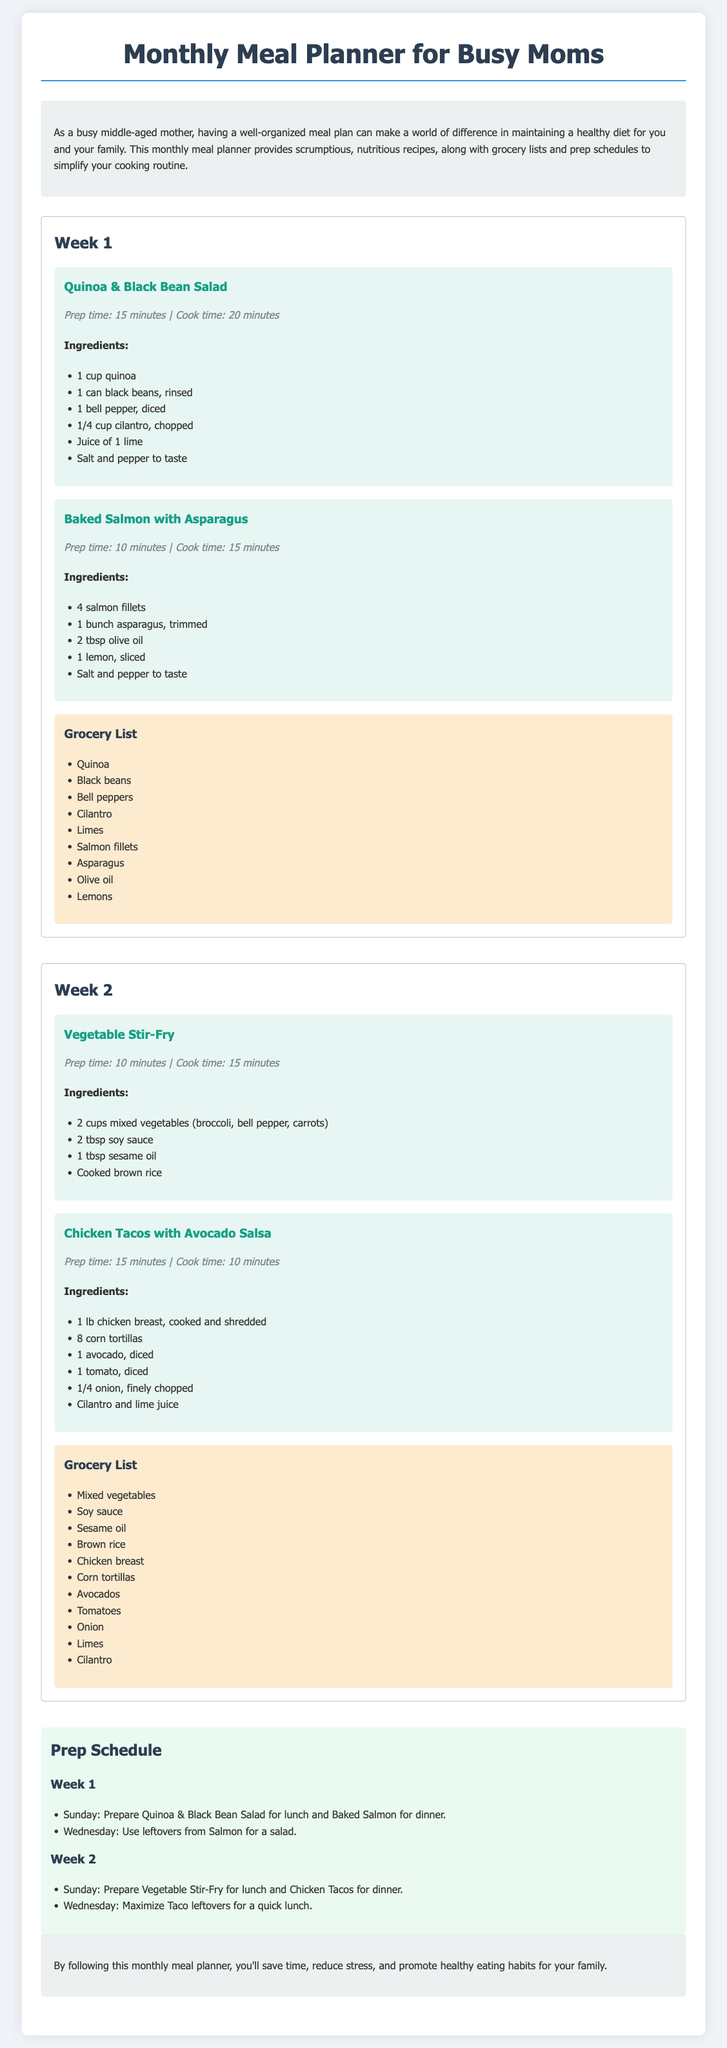What is the title of the document? The title appears prominently at the top of the document.
Answer: Monthly Meal Planner for Busy Moms How many recipes are listed in Week 1? The document outlines two recipes under Week 1.
Answer: 2 What is the prep time for Baked Salmon? The prep time is stated in the document under Baked Salmon.
Answer: 10 minutes Which ingredient is used in both weeks' recipes? Reviewing the ingredients lists for both weeks will show the common items.
Answer: Cilantro What is the total number of grocery items listed in Week 2? The grocery list for Week 2 includes ten distinct items.
Answer: 10 What is the main dish prepared on Sundays in Week 1? The document specifies the meals prepared on Sundays in the prep schedule for Week 1.
Answer: Quinoa & Black Bean Salad How many meals are indicated for Wednesday in Week 2? The document mentions one meal based on leftovers for Wednesday in Week 2.
Answer: 1 What cooking method is used for the Chicken Tacos? The preparation method is highlighted in the recipe description.
Answer: Shredded What color is associated with the recipe sections in the document? The background color of the recipe sections can be found in the style descriptions.
Answer: Light blue 